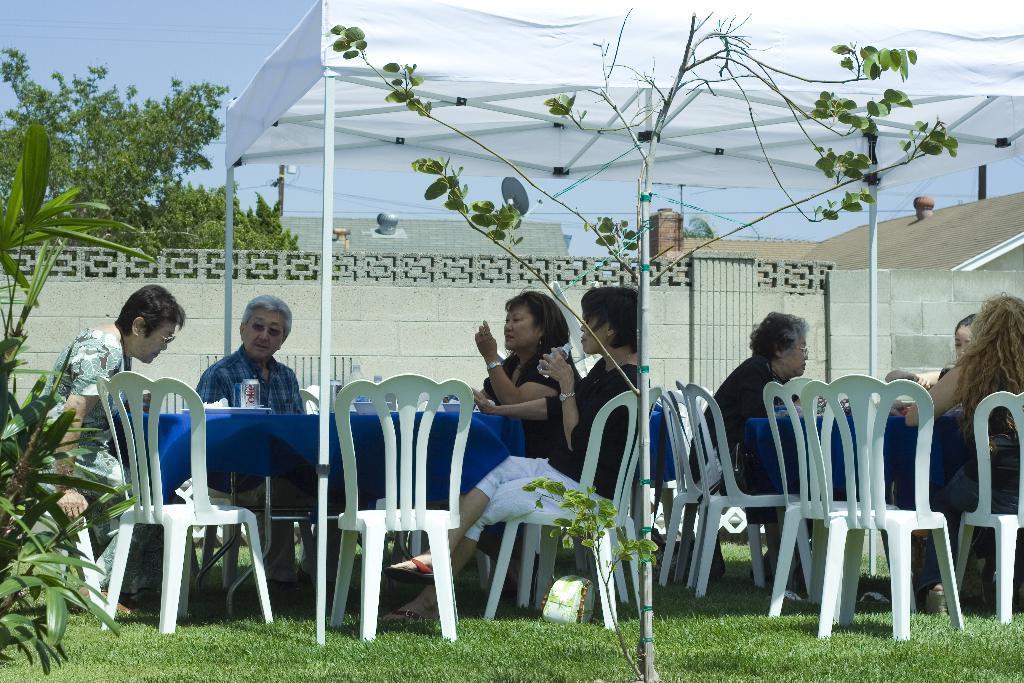Could you give a brief overview of what you see in this image? This image is taken in the garden , There is grass on the ground in the green color, There are some chairs which are in white color, There is a table covered by a blue cloth, there are some people sitting on the chairs, There is a white color shade, In the background there is a green color tree, There is a wall of white color. 